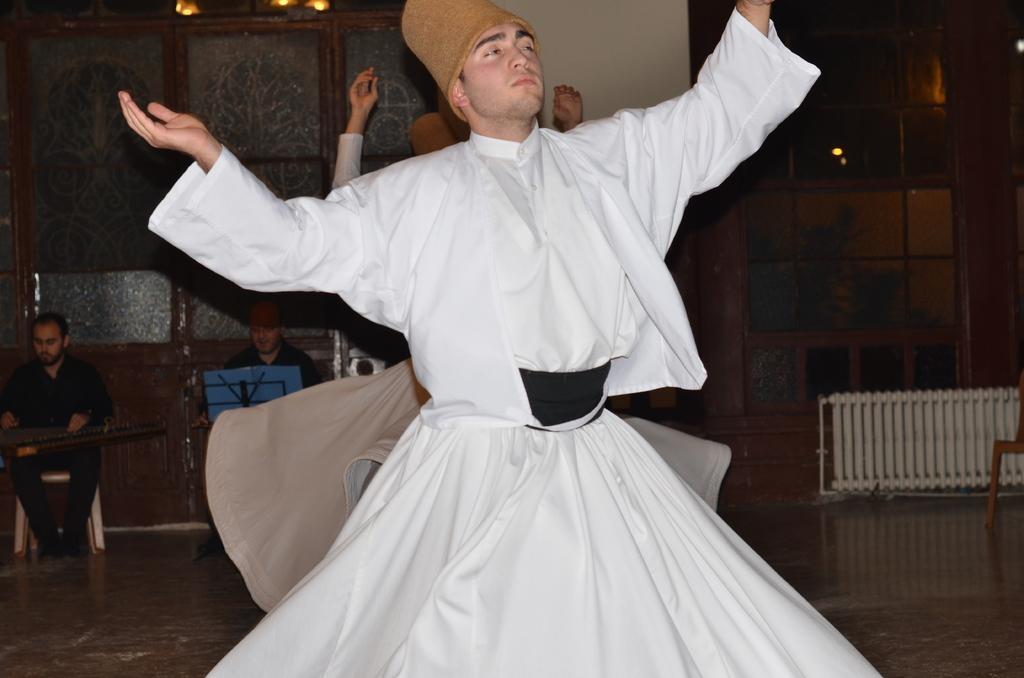Can you describe this image briefly? This picture is taken inside the room. In this image, in the middle, we can see a man wearing a white color dress is dancing. On the left side, we can also see another person wearing a black color dress is sitting on the chair and holding some object in his hand. On the right side, we can also see a chair, grill, glass window. In the background, we can see another person is dancing. In the background, we can also see another person sitting on the table, on the table, we can see a book which is in blue color. In the background, we can also see a glass. At the bottom, we can see a floor. 